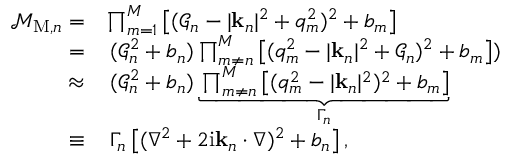<formula> <loc_0><loc_0><loc_500><loc_500>\begin{array} { r l } { \mathcal { M } _ { M , n } = } & { \prod _ { m = 1 } ^ { M } \left [ ( \mathcal { G } _ { n } - | k _ { n } | ^ { 2 } + q _ { m } ^ { 2 } ) ^ { 2 } + b _ { m } \right ] } \\ { = } & { \, ( \mathcal { G } _ { n } ^ { 2 } + b _ { n } ) \prod _ { m \neq n } ^ { M } \left [ ( q _ { m } ^ { 2 } - | k _ { n } | ^ { 2 } + \mathcal { G } _ { n } ) ^ { 2 } + b _ { m } \right ] ) } \\ { \approx } & { \, ( \mathcal { G } _ { n } ^ { 2 } + b _ { n } ) \underbrace { \prod _ { m \neq n } ^ { M } \left [ ( q _ { m } ^ { 2 } - | k _ { n } | ^ { 2 } ) ^ { 2 } + b _ { m } \right ] } _ { \Gamma _ { n } } } \\ { \equiv } & { \, \Gamma _ { n } \left [ ( \nabla ^ { 2 } + 2 i k _ { n } \cdot \nabla ) ^ { 2 } + b _ { n } \right ] , } \end{array}</formula> 